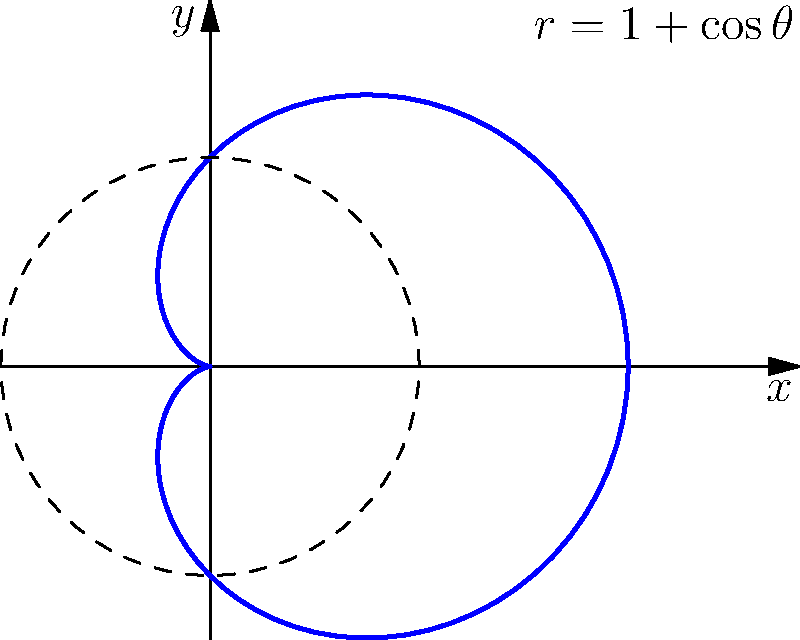Consider a 2D quantum wavefunction in Cartesian coordinates given by $\psi(x,y) = e^{-(x^2+y^2)/2}(x+iy)$. Transform this wavefunction to polar coordinates $(r,\theta)$ and determine the probability density $|\psi(r,\theta)|^2$. What is the shape of the probability distribution in polar coordinates? 1) First, we need to transform the wavefunction from Cartesian to polar coordinates:
   $x = r\cos\theta$, $y = r\sin\theta$
   
2) Substituting these into the original wavefunction:
   $\psi(r,\theta) = e^{-r^2/2}(r\cos\theta + ir\sin\theta)$
   
3) This can be simplified using Euler's formula:
   $\psi(r,\theta) = re^{-r^2/2}e^{i\theta}$

4) To find the probability density, we calculate $|\psi(r,\theta)|^2$:
   $|\psi(r,\theta)|^2 = |re^{-r^2/2}e^{i\theta}|^2 = r^2e^{-r^2}$

5) Notice that this expression is independent of $\theta$, which means the probability density is radially symmetric.

6) The shape of this distribution in polar coordinates is a circle with a radius where $r^2e^{-r^2}$ is maximum.

7) To find this radius, we differentiate $r^2e^{-r^2}$ with respect to $r$ and set it to zero:
   $\frac{d}{dr}(r^2e^{-r^2}) = 2re^{-r^2} - 2r^3e^{-r^2} = 0$
   $2re^{-r^2}(1-r^2) = 0$
   $r = 1$ (excluding $r=0$ as it's a minimum)

8) Therefore, the probability distribution forms a circular ring with radius 1, as shown in the polar plot.
Answer: Circular ring with radius 1 